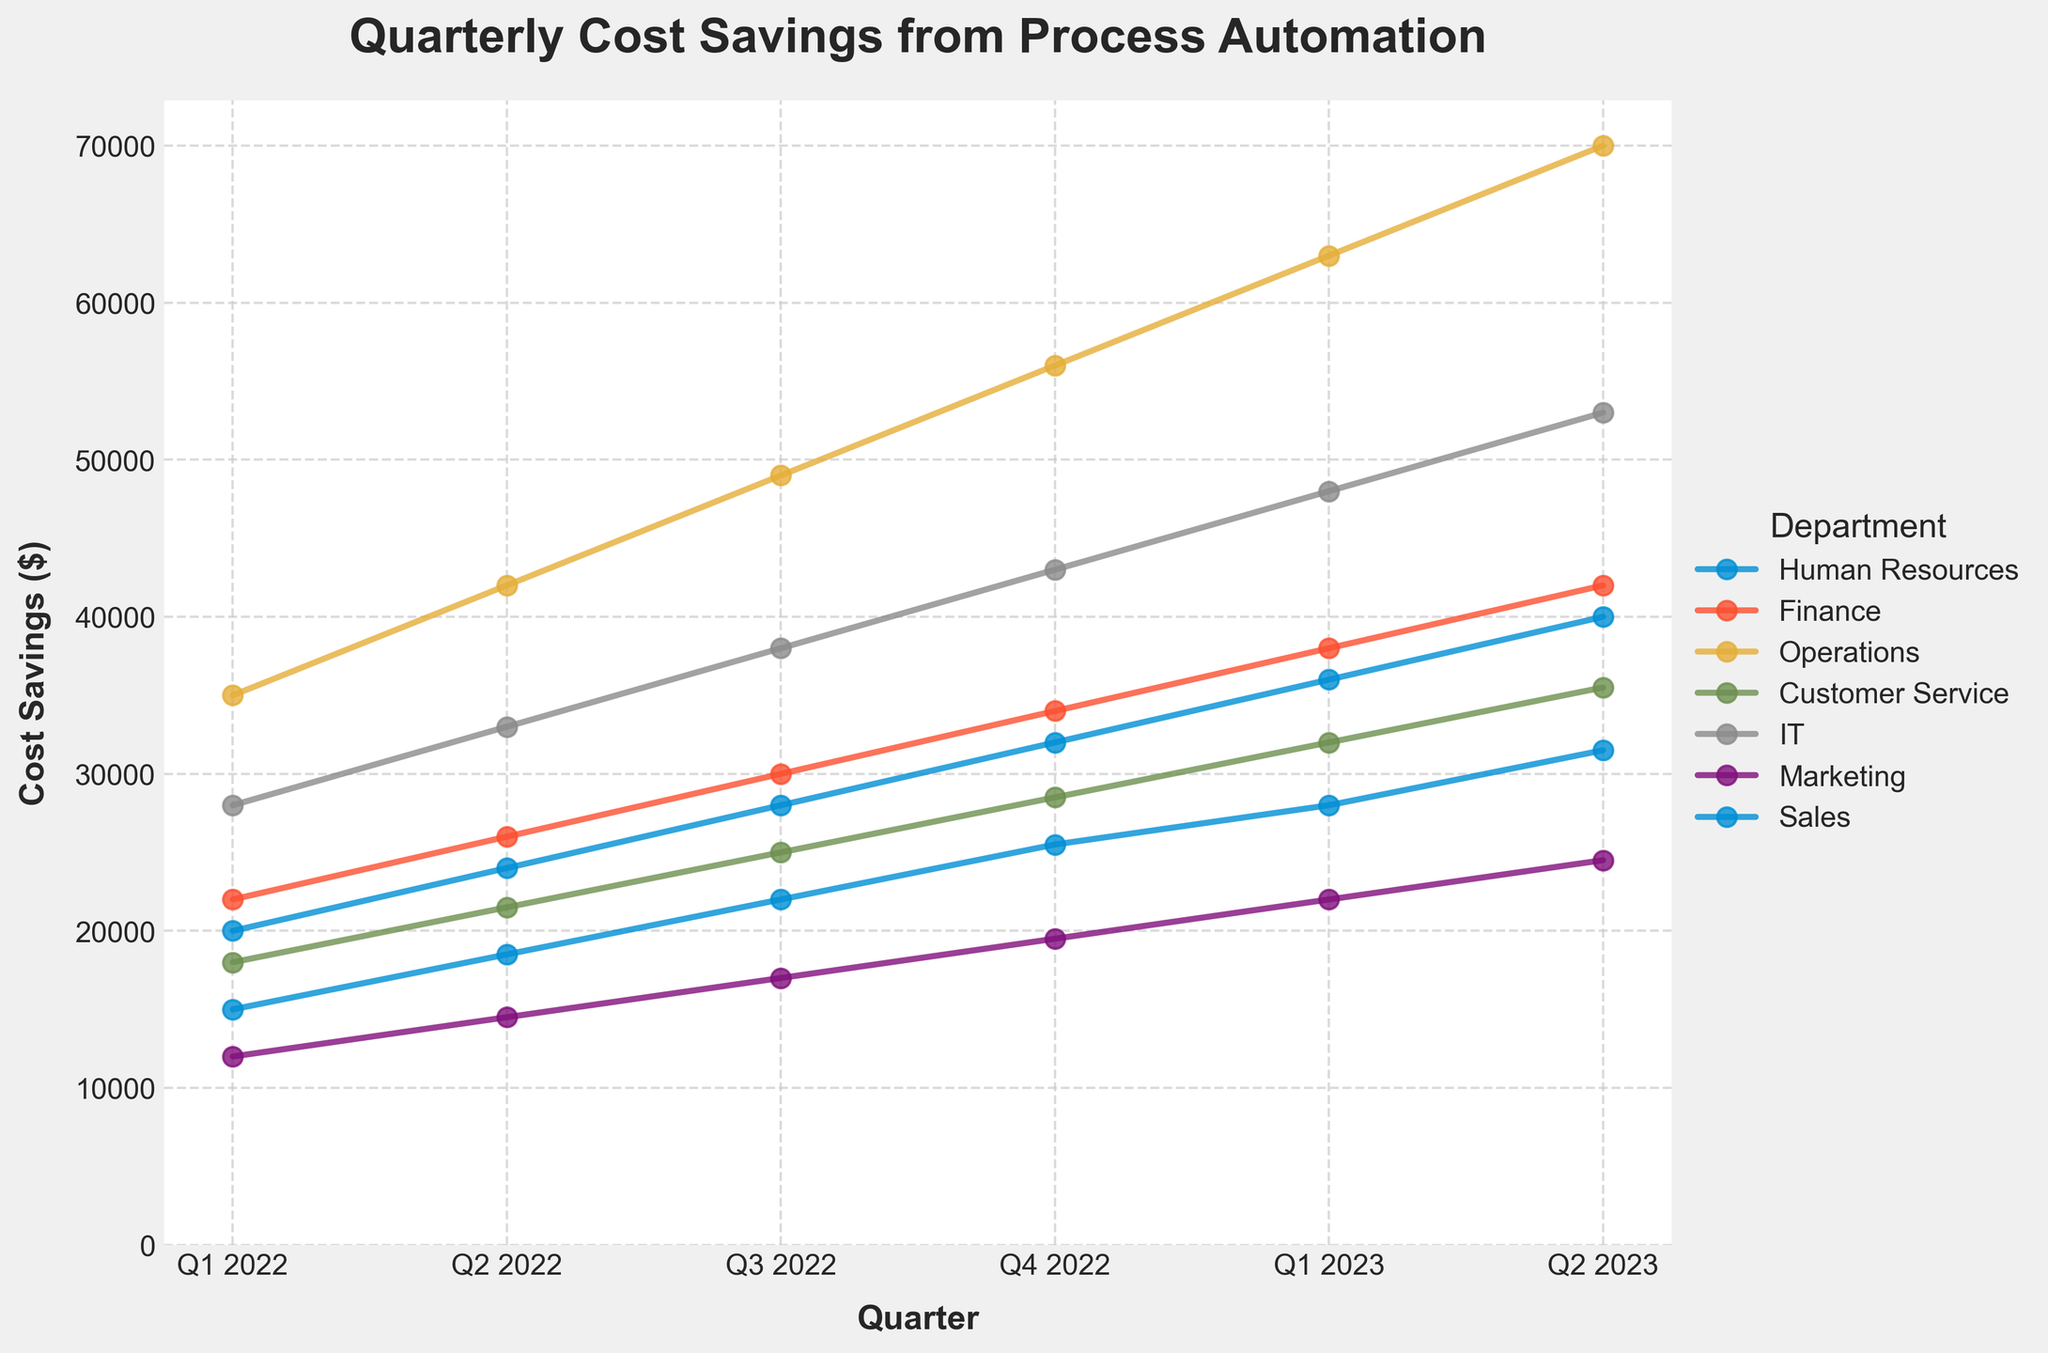Which department shows the highest cost savings in Q2 2023? The topmost line in Q2 2023 indicates the department with the highest cost savings. In Q2 2023, Operations is at the top with $70,000.
Answer: Operations What is the percentage increase in cost savings for IT from Q1 2022 to Q2 2023? (round to nearest whole number) Initially, IT's cost savings in Q1 2022 is $28,000 and in Q2 2023 it's $53,000. The increase is $53,000 - $28,000 = $25,000. The percentage increase is ($25,000 / $28,000) * 100 ≈ 89%.
Answer: 89% How do the cost savings of Sales in Q1 2023 compare to Finance in the same quarter? The line representing Sales in Q1 2023 reaches approximately $36,000, while the Finance line reaches $38,000.
Answer: Finance is higher than Sales Which quarter shows the biggest change in cost savings for Human Resources? By examining the slopes between points on the Human Resources line, the largest jump is between Q1 2022 ($15,000) and Q2 2022 ($18,500), a change of $3,500.
Answer: Q1 2022 to Q2 2022 What is the total cost savings for Marketing across all quarters? Sum the values for Marketing across all quarters: $12,000 + $14,500 + $17,000 + $19,500 + $22,000 + $24,500 = $109,500.
Answer: $109,500 Do any departments have the same cost savings in any quarter? By observing the lines, no two departments intersect at any points on the chart, indicating no shared cost savings values in any quarter.
Answer: No Which department had the smallest increase in cost savings between Q3 2022 and Q4 2022? The smallest increase is found by comparing the rise between Q3 2022 and Q4 2022 for each department. Marketing's increase of $19,500 - $17,000 = $2,500 is the smallest among all.
Answer: Marketing Is there a department whose cost savings improved consistently every quarter? By examining each department's line for consistent upward slopes without any quarterly decrease, all the depicted departments show consistent improvement every quarter.
Answer: Yes What's the average quarterly cost saving for Customer Service in 2022? Sum the savings for Customer Service across 2022: $18,000 + $21,500 + $25,000 + $28,500 = $93,000. The average is $93,000 / 4 = $23,250.
Answer: $23,250 How much more did Operations save in Q2 2023 compared to Finance? In Q2 2023, Operations saved $70,000 and Finance saved $42,000. The difference is $70,000 - $42,000 = $28,000.
Answer: $28,000 